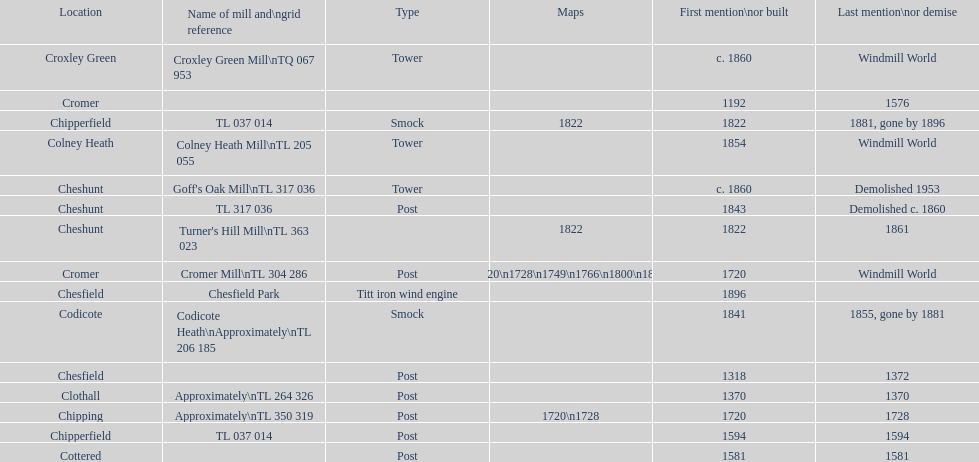How many mills were mentioned or built before 1700? 5. 